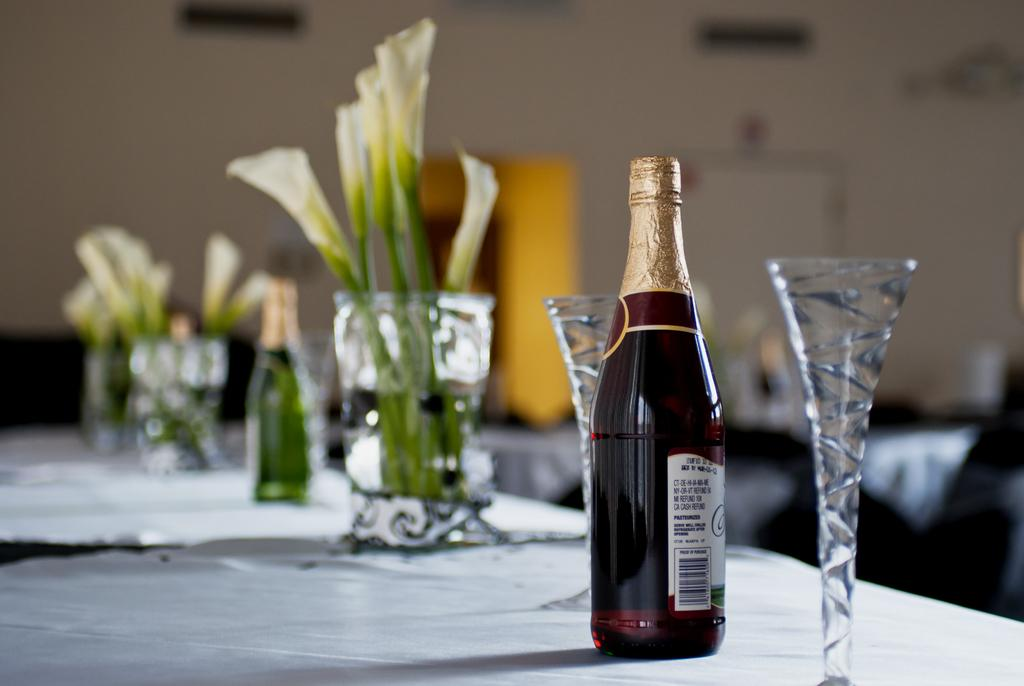What type of containers are present in the image? There are bottles and glasses in the image. Where are the bottles and glasses located? The bottles and glasses are on a platform. What other objects can be seen in the image? There are plants in the image. What is visible in the background of the image? There is a wall and objects visible in the background of the image. What type of animal is being used to serve the drinks in the image? There are no animals present in the image, and drinks are not being served by any living beings. 